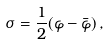<formula> <loc_0><loc_0><loc_500><loc_500>\sigma = { \frac { 1 } { 2 } } ( \varphi - \bar { \varphi } ) \, ,</formula> 